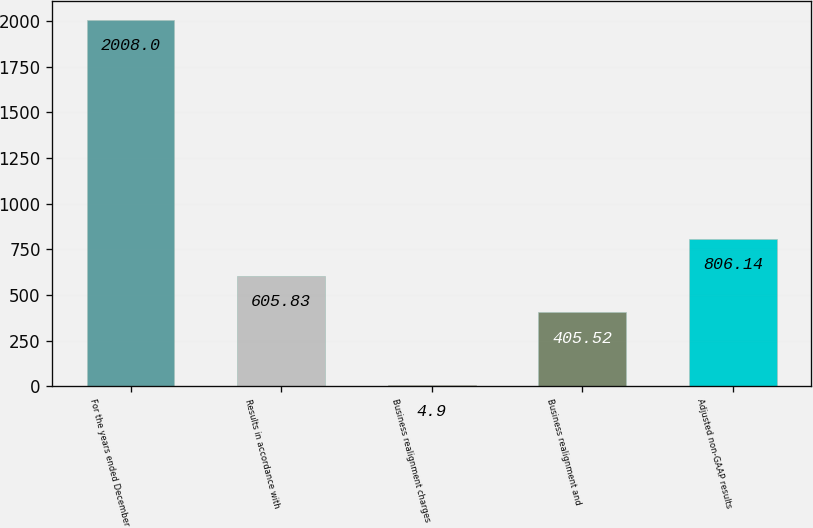Convert chart. <chart><loc_0><loc_0><loc_500><loc_500><bar_chart><fcel>For the years ended December<fcel>Results in accordance with<fcel>Business realignment charges<fcel>Business realignment and<fcel>Adjusted non-GAAP results<nl><fcel>2008<fcel>605.83<fcel>4.9<fcel>405.52<fcel>806.14<nl></chart> 